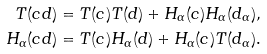<formula> <loc_0><loc_0><loc_500><loc_500>T ( c d ) = T ( c ) T ( d ) + H _ { \alpha } ( c ) H _ { \alpha } ( d _ { \alpha } ) , \\ H _ { \alpha } ( c d ) = T ( c ) H _ { \alpha } ( d ) + H _ { \alpha } ( c ) T ( d _ { \alpha } ) .</formula> 